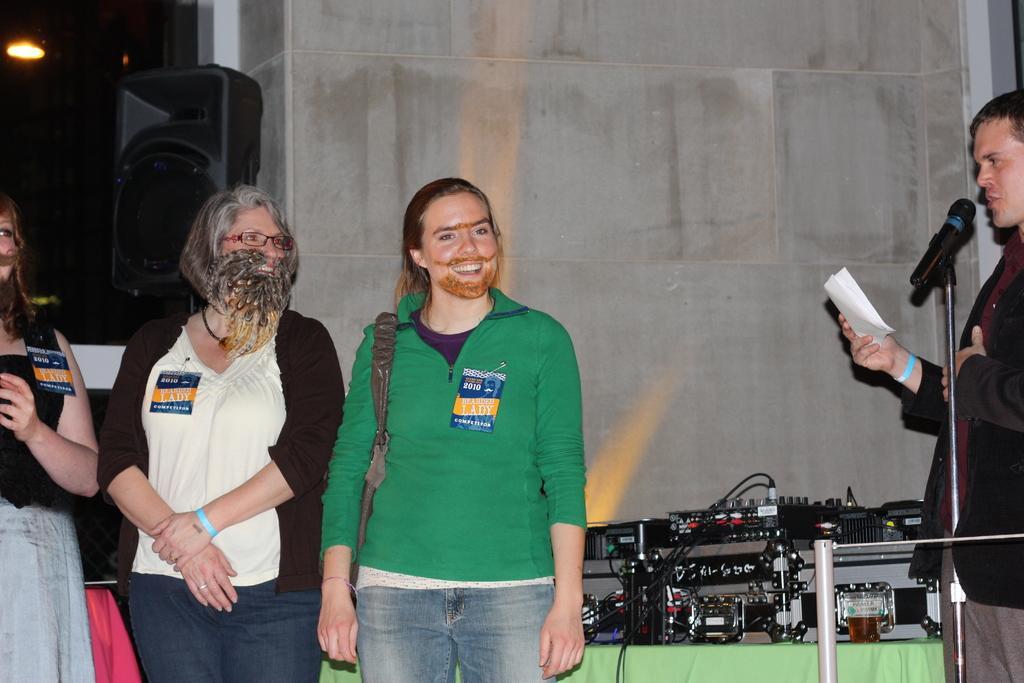Please provide a concise description of this image. In front of the picture, we see three women are standing. Three of them are smiling. On the right side, the man in black blazer is holding a paper in his hand and he is talking on the microphone. Beside him, we see a table which is covered with green color sheet. On the table, we see a music recorder. Behind them, we see a wall. Beside the wall, we see a speaker box. In the left top of the picture, we see the bulb. 